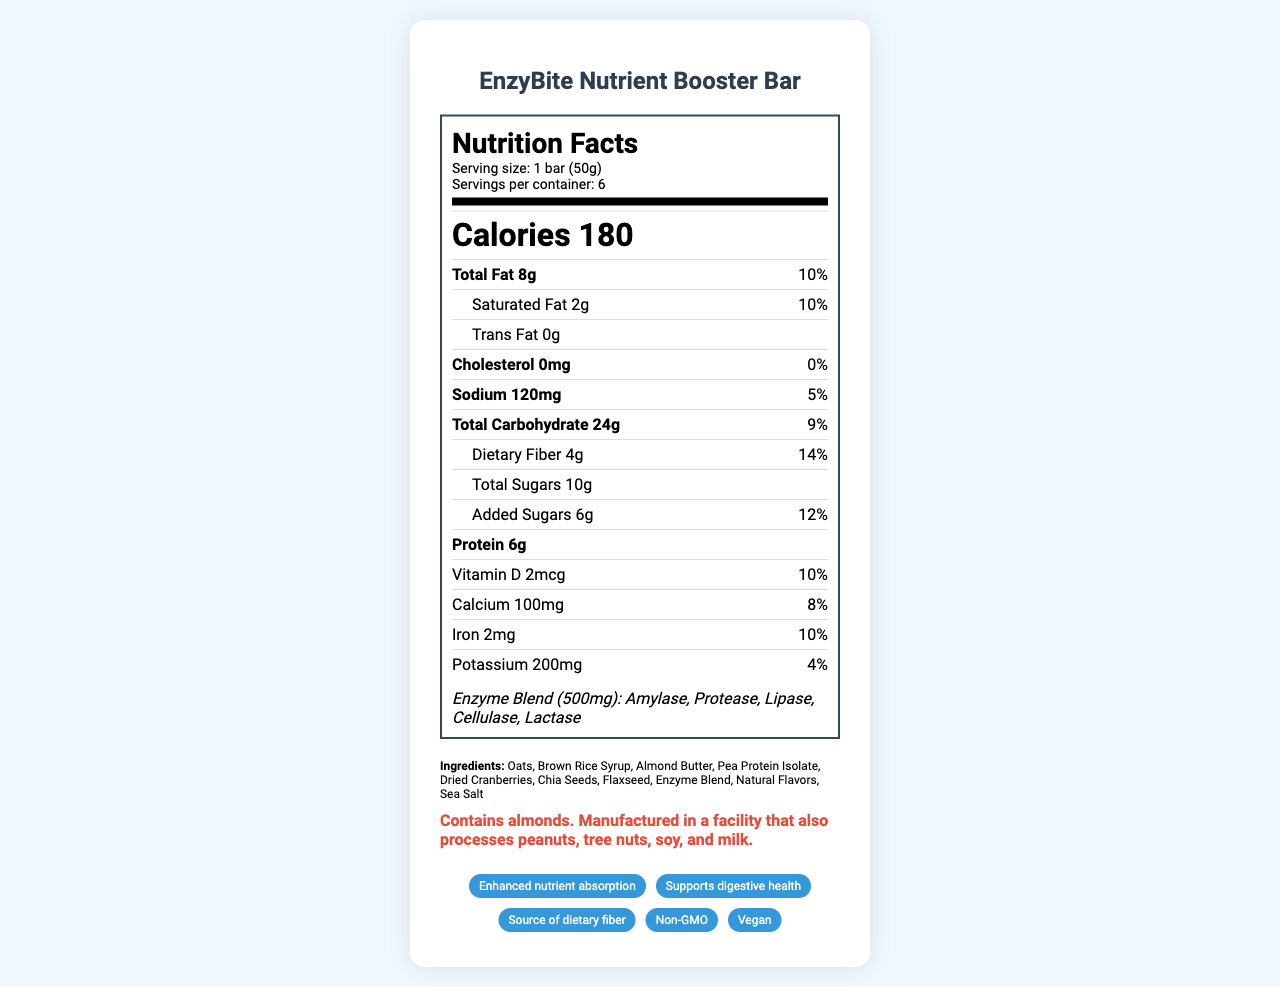what is the serving size? The serving size is listed at the top of the nutrition facts label as "Serving size: 1 bar (50g)".
Answer: 1 bar (50g) how many calories are in one serving? The calories per serving are prominently displayed near the top of the label as "Calories 180".
Answer: 180 what is the percentage of daily value of total fat per serving? The total fat daily value percentage is listed next to the total fat amount as "Total Fat 8g 10%".
Answer: 10% which ingredients are included in the enzyme blend? The enzyme blend ingredients are listed specifically in the enzyme blend section as "Enzyme Blend (500mg): Amylase, Protease, Lipase, Cellulase, Lactase".
Answer: Amylase, Protease, Lipase, Cellulase, Lactase what is the amount of added sugars per serving? The amount of added sugars is listed under the total sugars as "Added Sugars 6g 12%".
Answer: 6g how many grams of protein are in one bar? The protein content is listed near the middle of the label as "Protein 6g".
Answer: 6g how does the product support health? A. Enhances nutrient absorption B. Increases calorie intake C. Reduces cholesterol D. Increases sugar levels The claims section at the bottom of the label includes "Enhanced nutrient absorption".
Answer: A what is the daily value percentage for dietary fiber per serving? A. 5% B. 10% C. 14% D. 20% The daily value percentage for dietary fiber is listed as "Dietary Fiber 4g 14%".
Answer: C does the product contain any allergens? The allergen information is noted at the bottom as "Contains almonds. Manufactured in a facility that also processes peanuts, tree nuts, soy, and milk".
Answer: Yes is this product non-GMO? The claims section includes a badge that says "Non-GMO".
Answer: Yes summarize the main idea of the document. The document is a comprehensive nutrition facts label that highlights the nutritional content, ingredients, health benefits, and claims of EnzyBite Nutrient Booster Bar, along with allergen and storage information.
Answer: The document provides detailed nutritional information for EnzyBite Nutrient Booster Bar. It includes serving size, calorie count, breakdown of fats, cholesterol, sodium, carbohydrates, protein, and various vitamins and minerals. It emphasizes the inclusion of a proprietary enzyme blend to enhance nutrient absorption and claims such as supporting digestive health, being a source of dietary fiber, and being non-GMO and vegan. It also lists ingredients, allergen information, and storage instructions. how long should the product be consumed within after opening? The storage instructions specify "Consume within 3 days of opening".
Answer: 3 days what is the total carbohydrate content per serving? The total carbohydrate content is listed as "Total Carbohydrate 24g 9%".
Answer: 24g can this product be stored at room temperature? The storage instructions specify "Store in a cool, dry place", which implies room temperature is acceptable as long as it is cool and dry.
Answer: Yes what is the address of the manufacturer? The manufacturer information at the bottom of the label states "BioTech Nutrition Labs, 123 Innovation Way, Cambridge, MA 02142".
Answer: 123 Innovation Way, Cambridge, MA 02142 what is the optimized synergy mentioned in the research notes? The detailed mechanism or specific additional data about the optimized synergy of the enzyme blend with plant-based ingredients is not provided in the visual document.
Answer: Not enough information 